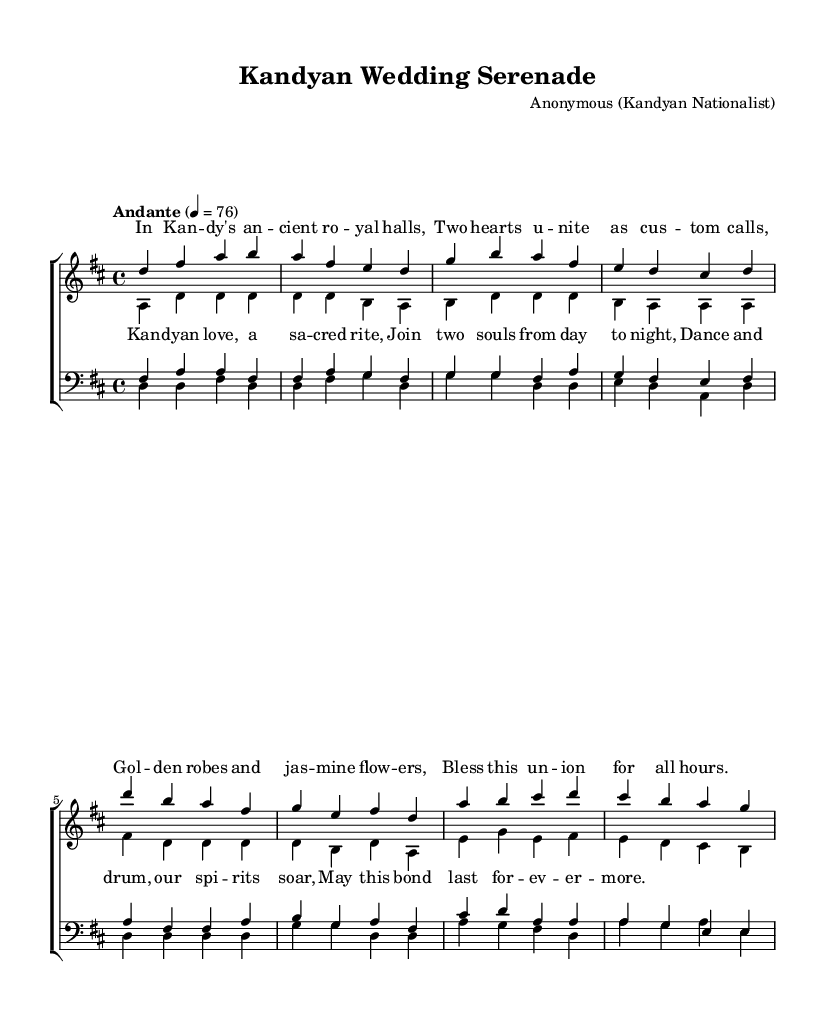What is the key signature of this music? The key signature indicated is D major, which has two sharps: F# and C#. This can be deduced from the key signature symbols shown at the beginning of the sheet music.
Answer: D major What is the time signature of the piece? The time signature is 4/4, as seen at the beginning of the score next to the key signature, which indicates four beats in each measure and a quarter note receives one beat.
Answer: 4/4 What is the tempo marking for this piece? The tempo marking shows "Andante" with a metronome marking of 76, suggesting a slow and moderate pace. This is located below the title at the beginning of the score.
Answer: Andante 76 How many verses are there in the lyrics? There are two distinct lyrical sections presented as verse and chorus. This is indicated by the labeling of sections within the lyrics.
Answer: Two Which voices are included in the choir staff? The choir staff includes soprano and alto voices for the women, and tenor and bass voices for the men, as noted by the labels "women" and "men" alongside respective staves.
Answer: Soprano, alto, tenor, bass What is the main theme of the opera as depicted in the lyrics? The main theme focuses on the union of two hearts and the celebration of a traditional Kandyan wedding, as highlighted in both the verse and the chorus through references to love and sacred rites.
Answer: Love and union 